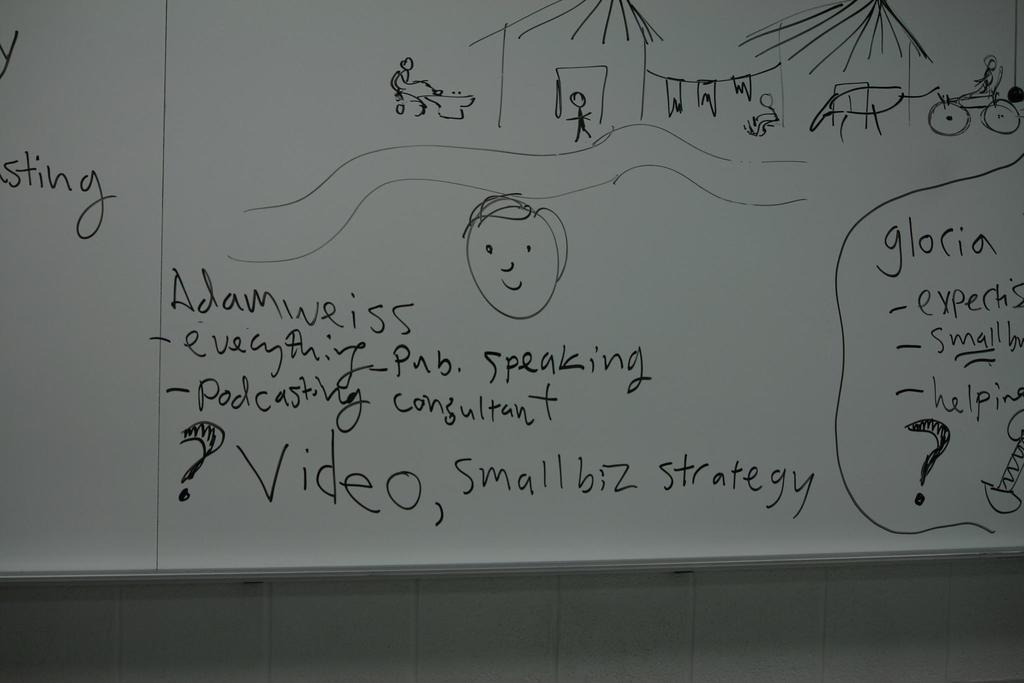Can you describe this image briefly? In this image we can see one white board with text and images attached to the wall. 